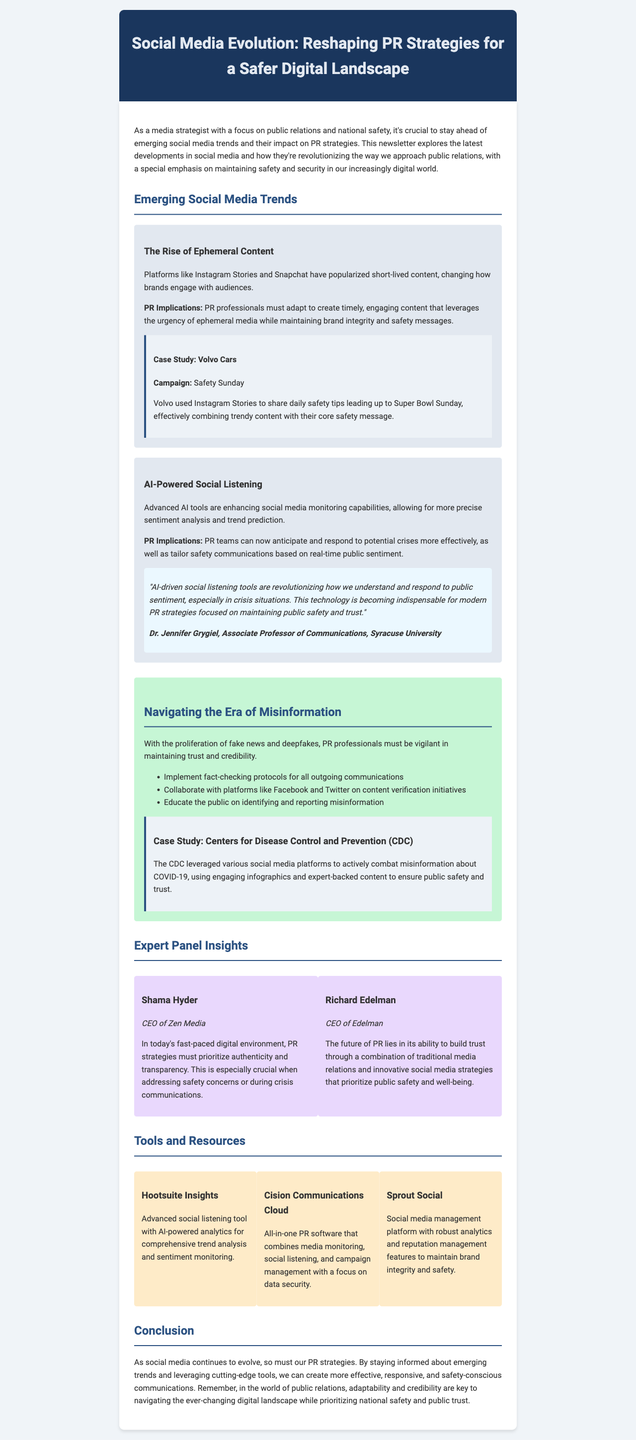What is the title of the newsletter? The title of the newsletter is stated prominently at the top of the document.
Answer: Social Media Evolution: Reshaping PR Strategies for a Safer Digital Landscape Who is the CEO of Zen Media? The newsletter includes a section with expert panel insights, listing the names and titles of contributors.
Answer: Shama Hyder What social media platforms are mentioned as popularizing ephemeral content? The document lists specific platforms associated with the trend of ephemeral content.
Answer: Instagram Stories and Snapchat What campaign did Volvo Cars launch? The case study section details a specific campaign related to Volvo's use of social media.
Answer: Safety Sunday What organization conducted the COVID-19 Mythbusters campaign? A case study highlights an organization's efforts to combat misinformation during a critical time.
Answer: Centers for Disease Control and Prevention (CDC) Which tool focuses on media monitoring and social listening? The tools and resources section lists various tools aimed at enhancing PR strategies.
Answer: Cision Communications Cloud What is a key point for navigating misinformation? The document outlines several strategies for addressing misinformation in PR.
Answer: Implement fact-checking protocols for all outgoing communications Which expert emphasizes the importance of authenticity in PR strategies? The expert panel section provides insights from various industry leaders regarding modern PR practices.
Answer: Shama Hyder What type of content is highlighted as changing audience engagement? The description of one trend discusses a specific type of content relevant to engagement strategies.
Answer: Ephemeral Content 